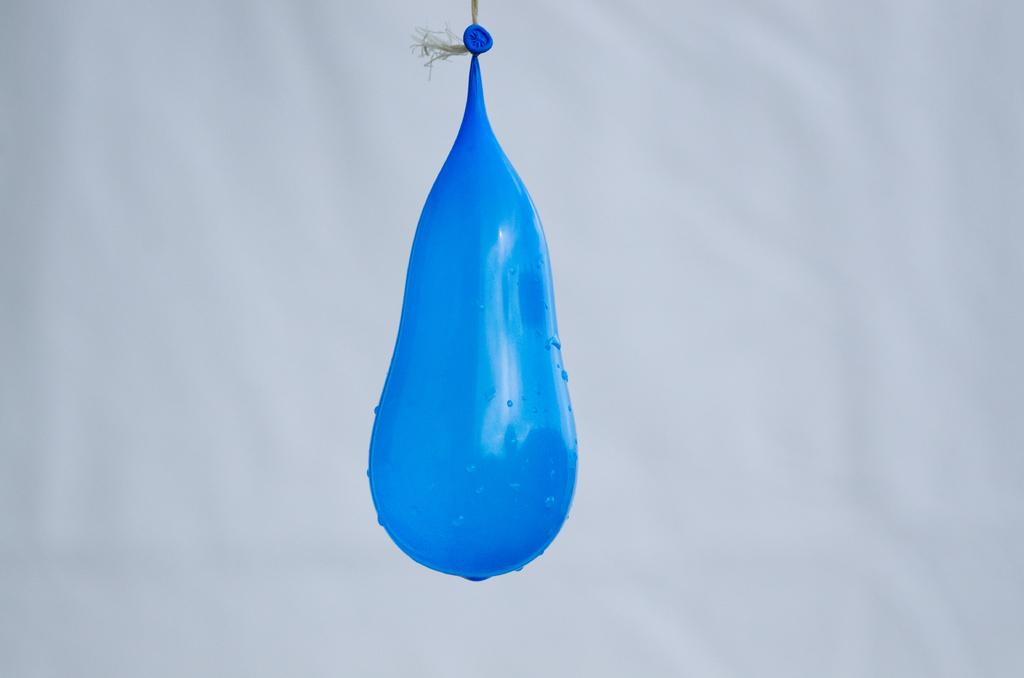What is the color of the balloon in the image? The balloon is blue. How is the balloon attached in the image? The balloon is tied with a thread. What can be seen on the surface of the balloon? There are water droplets on the balloon. What is the background color of the image? The background of the picture is white. Can you see the baby's toe in the image? There is no baby or toe present in the image; it features a blue balloon with water droplets and a white background. 